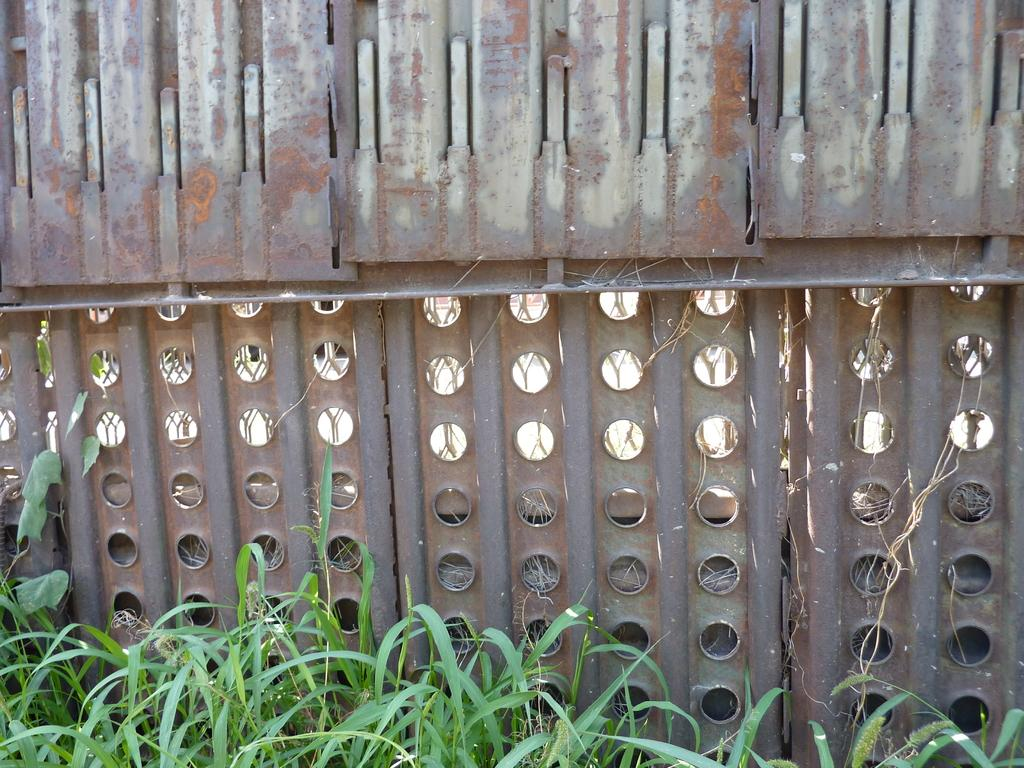What type of vegetation is visible in the image? There is grass in the image. What kind of barrier can be seen in the image? There is fencing in the image. What material is the wall in the image made of? The wall in the image is made of metal. Where is the pan located in the image? There is no pan present in the image. What is the name of the downtown area visible in the image? There is no downtown area visible in the image. How many visitors can be seen in the image? There are no visitors present in the image. 